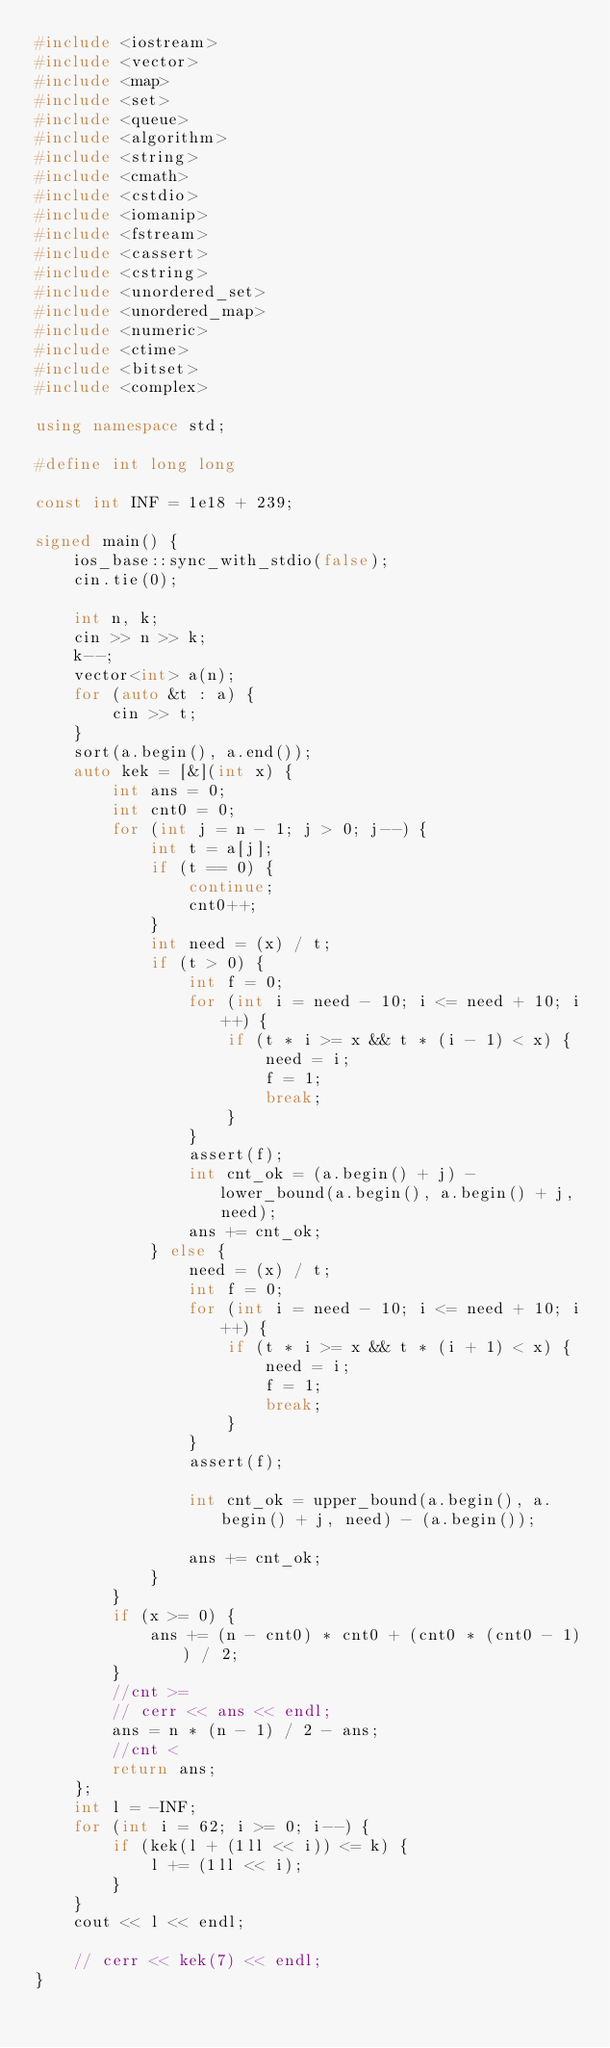Convert code to text. <code><loc_0><loc_0><loc_500><loc_500><_C++_>#include <iostream>
#include <vector>
#include <map>
#include <set>
#include <queue>
#include <algorithm>
#include <string>
#include <cmath>
#include <cstdio>
#include <iomanip>
#include <fstream>
#include <cassert>
#include <cstring>
#include <unordered_set>
#include <unordered_map>
#include <numeric>
#include <ctime>
#include <bitset>
#include <complex>

using namespace std;

#define int long long

const int INF = 1e18 + 239;

signed main() {
	ios_base::sync_with_stdio(false);
	cin.tie(0);

	int n, k;
	cin >> n >> k;
	k--;
	vector<int> a(n);
	for (auto &t : a) {
		cin >> t;
	} 
	sort(a.begin(), a.end());
	auto kek = [&](int x) {
		int ans = 0;
		int cnt0 = 0;
		for (int j = n - 1; j > 0; j--) {
			int t = a[j];
			if (t == 0) {
				continue;
				cnt0++;
			}
			int need = (x) / t;
			if (t > 0) {
				int f = 0;
				for (int i = need - 10; i <= need + 10; i++) {
					if (t * i >= x && t * (i - 1) < x) {
						need = i;
						f = 1;
						break;
					}
				}
				assert(f);
				int cnt_ok = (a.begin() + j) - lower_bound(a.begin(), a.begin() + j, need);
				ans += cnt_ok;
			} else {
				need = (x) / t;			
				int f = 0;
				for (int i = need - 10; i <= need + 10; i++) {
					if (t * i >= x && t * (i + 1) < x) {
						need = i;
						f = 1;
						break;
					}
				}
				assert(f);
				
				int cnt_ok = upper_bound(a.begin(), a.begin() + j, need) - (a.begin());

				ans += cnt_ok;
			}
		}
		if (x >= 0) {
			ans += (n - cnt0) * cnt0 + (cnt0 * (cnt0 - 1)) / 2;
		}
		//cnt >= 
		// cerr << ans << endl;
		ans = n * (n - 1) / 2 - ans;
		//cnt <
		return ans;
	};
	int l = -INF;
	for (int i = 62; i >= 0; i--) {
		if (kek(l + (1ll << i)) <= k) {
			l += (1ll << i);
		}
	}
	cout << l << endl;

	// cerr << kek(7) << endl;
}
</code> 